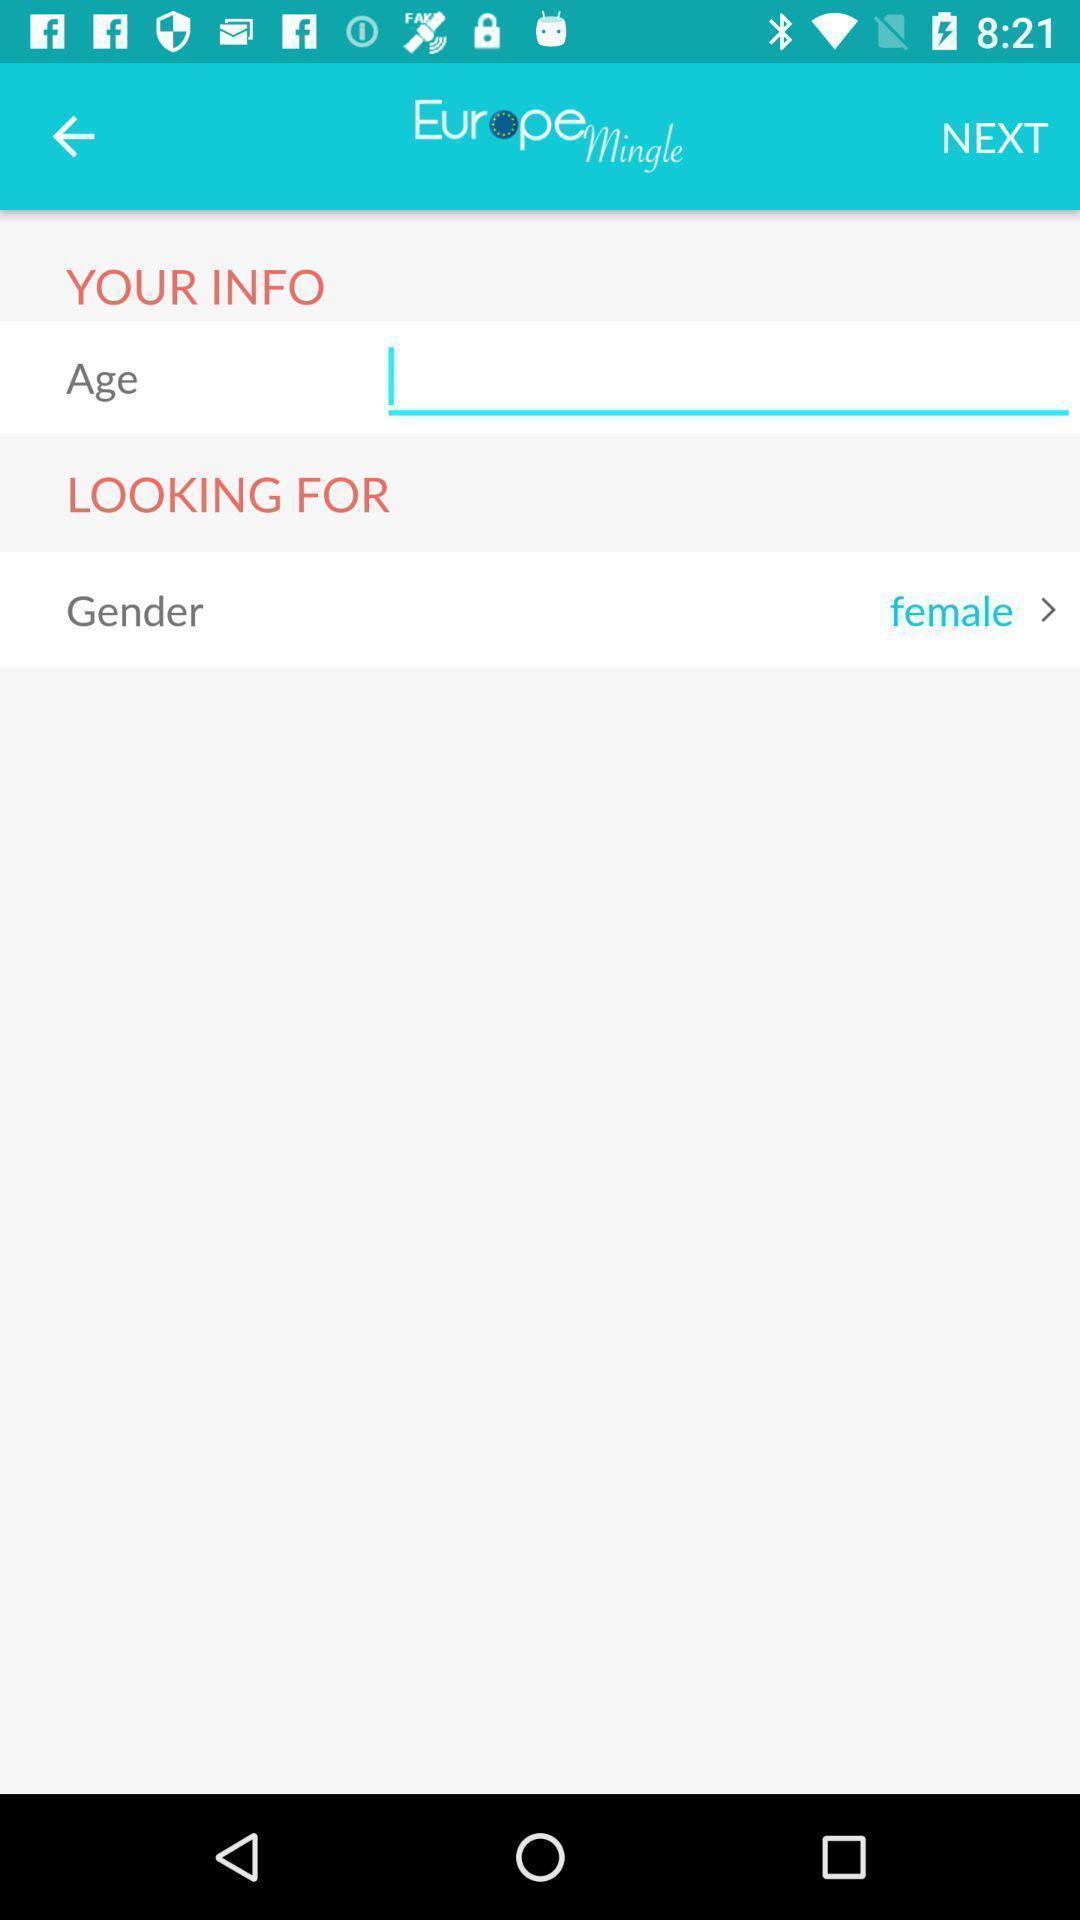Give me a summary of this screen capture. Screen page displaying various details with next option. 